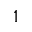Convert formula to latex. <formula><loc_0><loc_0><loc_500><loc_500>1</formula> 